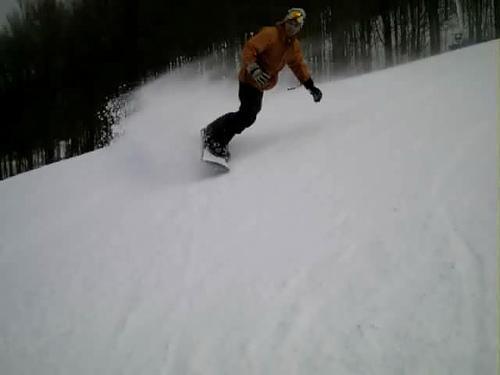How many people are there?
Give a very brief answer. 1. 